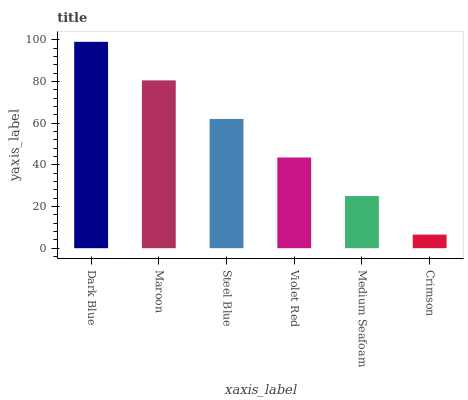Is Crimson the minimum?
Answer yes or no. Yes. Is Dark Blue the maximum?
Answer yes or no. Yes. Is Maroon the minimum?
Answer yes or no. No. Is Maroon the maximum?
Answer yes or no. No. Is Dark Blue greater than Maroon?
Answer yes or no. Yes. Is Maroon less than Dark Blue?
Answer yes or no. Yes. Is Maroon greater than Dark Blue?
Answer yes or no. No. Is Dark Blue less than Maroon?
Answer yes or no. No. Is Steel Blue the high median?
Answer yes or no. Yes. Is Violet Red the low median?
Answer yes or no. Yes. Is Medium Seafoam the high median?
Answer yes or no. No. Is Dark Blue the low median?
Answer yes or no. No. 